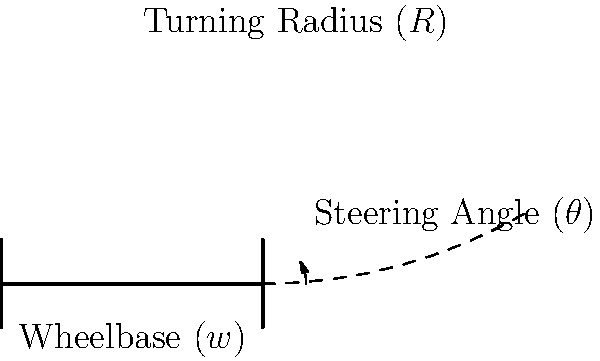A high-performance sports car has a wheelbase of 2.8 meters and can achieve a maximum steering angle of 35 degrees. Calculate the minimum turning radius of this car, assuming it follows the Ackermann steering geometry. Round your answer to the nearest centimeter. To calculate the minimum turning radius of the car, we'll use the formula derived from Ackermann steering geometry:

$$R = \frac{w}{\sin(\theta)}$$

Where:
$R$ = turning radius
$w$ = wheelbase
$\theta$ = steering angle

Given:
$w = 2.8$ meters
$\theta = 35$ degrees

Step 1: Convert the steering angle to radians:
$$35° \times \frac{\pi}{180°} = 0.6109 \text{ radians}$$

Step 2: Apply the formula:
$$R = \frac{2.8}{\sin(0.6109)}$$

Step 3: Calculate the result:
$$R = \frac{2.8}{0.5877} = 4.7643 \text{ meters}$$

Step 4: Round to the nearest centimeter:
$$4.76 \text{ meters}$$

This calculation gives us the minimum turning radius of the car, which is the distance from the center of the turning circle to the outer wheel's path.
Answer: 4.76 meters 